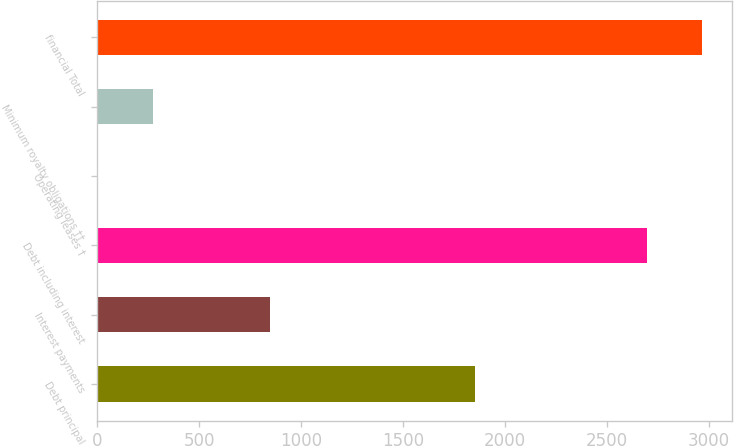Convert chart to OTSL. <chart><loc_0><loc_0><loc_500><loc_500><bar_chart><fcel>Debt principal<fcel>Interest payments<fcel>Debt including interest<fcel>Operating leases †<fcel>Minimum royalty obligations ††<fcel>financial Total<nl><fcel>1852<fcel>846<fcel>2698<fcel>2<fcel>272.6<fcel>2968.6<nl></chart> 